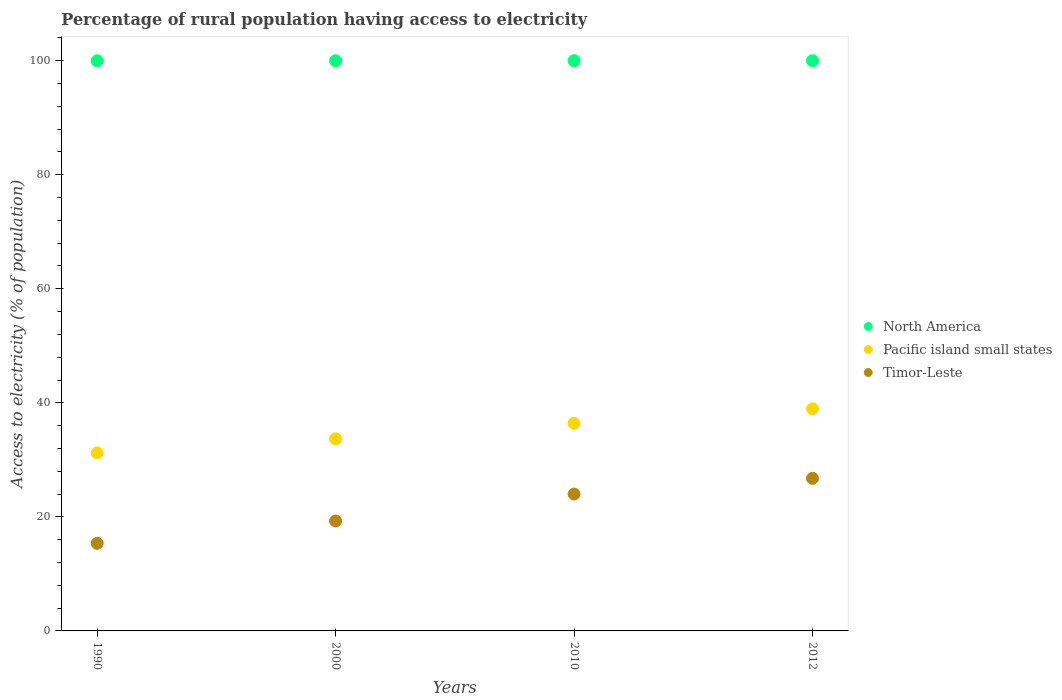Is the number of dotlines equal to the number of legend labels?
Give a very brief answer. Yes. What is the percentage of rural population having access to electricity in Timor-Leste in 2010?
Keep it short and to the point. 24. Across all years, what is the maximum percentage of rural population having access to electricity in Timor-Leste?
Your response must be concise. 26.75. Across all years, what is the minimum percentage of rural population having access to electricity in North America?
Your answer should be compact. 100. What is the total percentage of rural population having access to electricity in North America in the graph?
Provide a succinct answer. 400. What is the difference between the percentage of rural population having access to electricity in Pacific island small states in 2000 and that in 2010?
Your answer should be compact. -2.71. What is the difference between the percentage of rural population having access to electricity in Timor-Leste in 2000 and the percentage of rural population having access to electricity in Pacific island small states in 1990?
Your answer should be very brief. -11.94. What is the average percentage of rural population having access to electricity in Timor-Leste per year?
Offer a terse response. 21.35. In the year 2012, what is the difference between the percentage of rural population having access to electricity in North America and percentage of rural population having access to electricity in Timor-Leste?
Offer a very short reply. 73.25. In how many years, is the percentage of rural population having access to electricity in North America greater than 88 %?
Make the answer very short. 4. What is the ratio of the percentage of rural population having access to electricity in Pacific island small states in 1990 to that in 2010?
Give a very brief answer. 0.86. What is the difference between the highest and the second highest percentage of rural population having access to electricity in North America?
Offer a very short reply. 0. What is the difference between the highest and the lowest percentage of rural population having access to electricity in Pacific island small states?
Make the answer very short. 7.73. Is it the case that in every year, the sum of the percentage of rural population having access to electricity in North America and percentage of rural population having access to electricity in Timor-Leste  is greater than the percentage of rural population having access to electricity in Pacific island small states?
Your answer should be very brief. Yes. Does the percentage of rural population having access to electricity in Pacific island small states monotonically increase over the years?
Offer a very short reply. Yes. Is the percentage of rural population having access to electricity in Timor-Leste strictly greater than the percentage of rural population having access to electricity in Pacific island small states over the years?
Provide a short and direct response. No. How many dotlines are there?
Keep it short and to the point. 3. What is the difference between two consecutive major ticks on the Y-axis?
Provide a short and direct response. 20. Are the values on the major ticks of Y-axis written in scientific E-notation?
Your answer should be very brief. No. Does the graph contain grids?
Keep it short and to the point. No. Where does the legend appear in the graph?
Your response must be concise. Center right. How are the legend labels stacked?
Your response must be concise. Vertical. What is the title of the graph?
Offer a very short reply. Percentage of rural population having access to electricity. Does "Sub-Saharan Africa (all income levels)" appear as one of the legend labels in the graph?
Give a very brief answer. No. What is the label or title of the X-axis?
Keep it short and to the point. Years. What is the label or title of the Y-axis?
Offer a terse response. Access to electricity (% of population). What is the Access to electricity (% of population) of Pacific island small states in 1990?
Keep it short and to the point. 31.22. What is the Access to electricity (% of population) in Timor-Leste in 1990?
Give a very brief answer. 15.36. What is the Access to electricity (% of population) in Pacific island small states in 2000?
Make the answer very short. 33.69. What is the Access to electricity (% of population) of Timor-Leste in 2000?
Make the answer very short. 19.28. What is the Access to electricity (% of population) of North America in 2010?
Offer a very short reply. 100. What is the Access to electricity (% of population) in Pacific island small states in 2010?
Keep it short and to the point. 36.4. What is the Access to electricity (% of population) in Timor-Leste in 2010?
Make the answer very short. 24. What is the Access to electricity (% of population) of Pacific island small states in 2012?
Provide a short and direct response. 38.94. What is the Access to electricity (% of population) of Timor-Leste in 2012?
Your answer should be very brief. 26.75. Across all years, what is the maximum Access to electricity (% of population) in Pacific island small states?
Make the answer very short. 38.94. Across all years, what is the maximum Access to electricity (% of population) in Timor-Leste?
Your answer should be compact. 26.75. Across all years, what is the minimum Access to electricity (% of population) of Pacific island small states?
Your response must be concise. 31.22. Across all years, what is the minimum Access to electricity (% of population) in Timor-Leste?
Make the answer very short. 15.36. What is the total Access to electricity (% of population) in Pacific island small states in the graph?
Your response must be concise. 140.25. What is the total Access to electricity (% of population) of Timor-Leste in the graph?
Give a very brief answer. 85.4. What is the difference between the Access to electricity (% of population) in Pacific island small states in 1990 and that in 2000?
Make the answer very short. -2.47. What is the difference between the Access to electricity (% of population) in Timor-Leste in 1990 and that in 2000?
Your answer should be compact. -3.92. What is the difference between the Access to electricity (% of population) in Pacific island small states in 1990 and that in 2010?
Ensure brevity in your answer.  -5.18. What is the difference between the Access to electricity (% of population) in Timor-Leste in 1990 and that in 2010?
Keep it short and to the point. -8.64. What is the difference between the Access to electricity (% of population) in North America in 1990 and that in 2012?
Keep it short and to the point. 0. What is the difference between the Access to electricity (% of population) of Pacific island small states in 1990 and that in 2012?
Your answer should be very brief. -7.73. What is the difference between the Access to electricity (% of population) of Timor-Leste in 1990 and that in 2012?
Offer a very short reply. -11.39. What is the difference between the Access to electricity (% of population) of Pacific island small states in 2000 and that in 2010?
Ensure brevity in your answer.  -2.71. What is the difference between the Access to electricity (% of population) of Timor-Leste in 2000 and that in 2010?
Provide a short and direct response. -4.72. What is the difference between the Access to electricity (% of population) in Pacific island small states in 2000 and that in 2012?
Offer a terse response. -5.26. What is the difference between the Access to electricity (% of population) of Timor-Leste in 2000 and that in 2012?
Your answer should be compact. -7.47. What is the difference between the Access to electricity (% of population) of Pacific island small states in 2010 and that in 2012?
Offer a very short reply. -2.54. What is the difference between the Access to electricity (% of population) of Timor-Leste in 2010 and that in 2012?
Offer a terse response. -2.75. What is the difference between the Access to electricity (% of population) in North America in 1990 and the Access to electricity (% of population) in Pacific island small states in 2000?
Ensure brevity in your answer.  66.31. What is the difference between the Access to electricity (% of population) of North America in 1990 and the Access to electricity (% of population) of Timor-Leste in 2000?
Provide a succinct answer. 80.72. What is the difference between the Access to electricity (% of population) of Pacific island small states in 1990 and the Access to electricity (% of population) of Timor-Leste in 2000?
Provide a succinct answer. 11.94. What is the difference between the Access to electricity (% of population) in North America in 1990 and the Access to electricity (% of population) in Pacific island small states in 2010?
Offer a terse response. 63.6. What is the difference between the Access to electricity (% of population) in North America in 1990 and the Access to electricity (% of population) in Timor-Leste in 2010?
Provide a succinct answer. 76. What is the difference between the Access to electricity (% of population) of Pacific island small states in 1990 and the Access to electricity (% of population) of Timor-Leste in 2010?
Offer a very short reply. 7.22. What is the difference between the Access to electricity (% of population) of North America in 1990 and the Access to electricity (% of population) of Pacific island small states in 2012?
Offer a very short reply. 61.06. What is the difference between the Access to electricity (% of population) in North America in 1990 and the Access to electricity (% of population) in Timor-Leste in 2012?
Provide a succinct answer. 73.25. What is the difference between the Access to electricity (% of population) of Pacific island small states in 1990 and the Access to electricity (% of population) of Timor-Leste in 2012?
Offer a very short reply. 4.46. What is the difference between the Access to electricity (% of population) of North America in 2000 and the Access to electricity (% of population) of Pacific island small states in 2010?
Make the answer very short. 63.6. What is the difference between the Access to electricity (% of population) in Pacific island small states in 2000 and the Access to electricity (% of population) in Timor-Leste in 2010?
Provide a short and direct response. 9.69. What is the difference between the Access to electricity (% of population) in North America in 2000 and the Access to electricity (% of population) in Pacific island small states in 2012?
Ensure brevity in your answer.  61.06. What is the difference between the Access to electricity (% of population) of North America in 2000 and the Access to electricity (% of population) of Timor-Leste in 2012?
Give a very brief answer. 73.25. What is the difference between the Access to electricity (% of population) in Pacific island small states in 2000 and the Access to electricity (% of population) in Timor-Leste in 2012?
Offer a terse response. 6.93. What is the difference between the Access to electricity (% of population) of North America in 2010 and the Access to electricity (% of population) of Pacific island small states in 2012?
Provide a succinct answer. 61.06. What is the difference between the Access to electricity (% of population) of North America in 2010 and the Access to electricity (% of population) of Timor-Leste in 2012?
Ensure brevity in your answer.  73.25. What is the difference between the Access to electricity (% of population) of Pacific island small states in 2010 and the Access to electricity (% of population) of Timor-Leste in 2012?
Offer a terse response. 9.65. What is the average Access to electricity (% of population) in North America per year?
Provide a short and direct response. 100. What is the average Access to electricity (% of population) in Pacific island small states per year?
Ensure brevity in your answer.  35.06. What is the average Access to electricity (% of population) in Timor-Leste per year?
Make the answer very short. 21.35. In the year 1990, what is the difference between the Access to electricity (% of population) of North America and Access to electricity (% of population) of Pacific island small states?
Give a very brief answer. 68.78. In the year 1990, what is the difference between the Access to electricity (% of population) in North America and Access to electricity (% of population) in Timor-Leste?
Your answer should be very brief. 84.64. In the year 1990, what is the difference between the Access to electricity (% of population) of Pacific island small states and Access to electricity (% of population) of Timor-Leste?
Your answer should be very brief. 15.86. In the year 2000, what is the difference between the Access to electricity (% of population) in North America and Access to electricity (% of population) in Pacific island small states?
Provide a short and direct response. 66.31. In the year 2000, what is the difference between the Access to electricity (% of population) in North America and Access to electricity (% of population) in Timor-Leste?
Provide a short and direct response. 80.72. In the year 2000, what is the difference between the Access to electricity (% of population) of Pacific island small states and Access to electricity (% of population) of Timor-Leste?
Your response must be concise. 14.41. In the year 2010, what is the difference between the Access to electricity (% of population) of North America and Access to electricity (% of population) of Pacific island small states?
Make the answer very short. 63.6. In the year 2010, what is the difference between the Access to electricity (% of population) in Pacific island small states and Access to electricity (% of population) in Timor-Leste?
Your answer should be compact. 12.4. In the year 2012, what is the difference between the Access to electricity (% of population) of North America and Access to electricity (% of population) of Pacific island small states?
Offer a very short reply. 61.06. In the year 2012, what is the difference between the Access to electricity (% of population) in North America and Access to electricity (% of population) in Timor-Leste?
Your answer should be compact. 73.25. In the year 2012, what is the difference between the Access to electricity (% of population) in Pacific island small states and Access to electricity (% of population) in Timor-Leste?
Offer a very short reply. 12.19. What is the ratio of the Access to electricity (% of population) in Pacific island small states in 1990 to that in 2000?
Make the answer very short. 0.93. What is the ratio of the Access to electricity (% of population) in Timor-Leste in 1990 to that in 2000?
Offer a very short reply. 0.8. What is the ratio of the Access to electricity (% of population) of North America in 1990 to that in 2010?
Offer a very short reply. 1. What is the ratio of the Access to electricity (% of population) of Pacific island small states in 1990 to that in 2010?
Make the answer very short. 0.86. What is the ratio of the Access to electricity (% of population) of Timor-Leste in 1990 to that in 2010?
Give a very brief answer. 0.64. What is the ratio of the Access to electricity (% of population) in Pacific island small states in 1990 to that in 2012?
Provide a succinct answer. 0.8. What is the ratio of the Access to electricity (% of population) in Timor-Leste in 1990 to that in 2012?
Your answer should be compact. 0.57. What is the ratio of the Access to electricity (% of population) in Pacific island small states in 2000 to that in 2010?
Provide a short and direct response. 0.93. What is the ratio of the Access to electricity (% of population) in Timor-Leste in 2000 to that in 2010?
Your response must be concise. 0.8. What is the ratio of the Access to electricity (% of population) in Pacific island small states in 2000 to that in 2012?
Provide a succinct answer. 0.87. What is the ratio of the Access to electricity (% of population) in Timor-Leste in 2000 to that in 2012?
Offer a terse response. 0.72. What is the ratio of the Access to electricity (% of population) in North America in 2010 to that in 2012?
Your answer should be very brief. 1. What is the ratio of the Access to electricity (% of population) of Pacific island small states in 2010 to that in 2012?
Offer a terse response. 0.93. What is the ratio of the Access to electricity (% of population) of Timor-Leste in 2010 to that in 2012?
Offer a terse response. 0.9. What is the difference between the highest and the second highest Access to electricity (% of population) of Pacific island small states?
Your answer should be very brief. 2.54. What is the difference between the highest and the second highest Access to electricity (% of population) in Timor-Leste?
Give a very brief answer. 2.75. What is the difference between the highest and the lowest Access to electricity (% of population) in Pacific island small states?
Your answer should be compact. 7.73. What is the difference between the highest and the lowest Access to electricity (% of population) in Timor-Leste?
Make the answer very short. 11.39. 